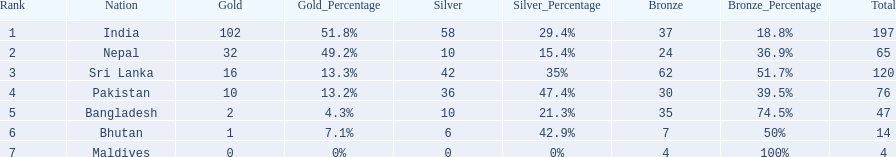What are the nations? India, Nepal, Sri Lanka, Pakistan, Bangladesh, Bhutan, Maldives. Of these, which one has earned the least amount of gold medals? Maldives. 